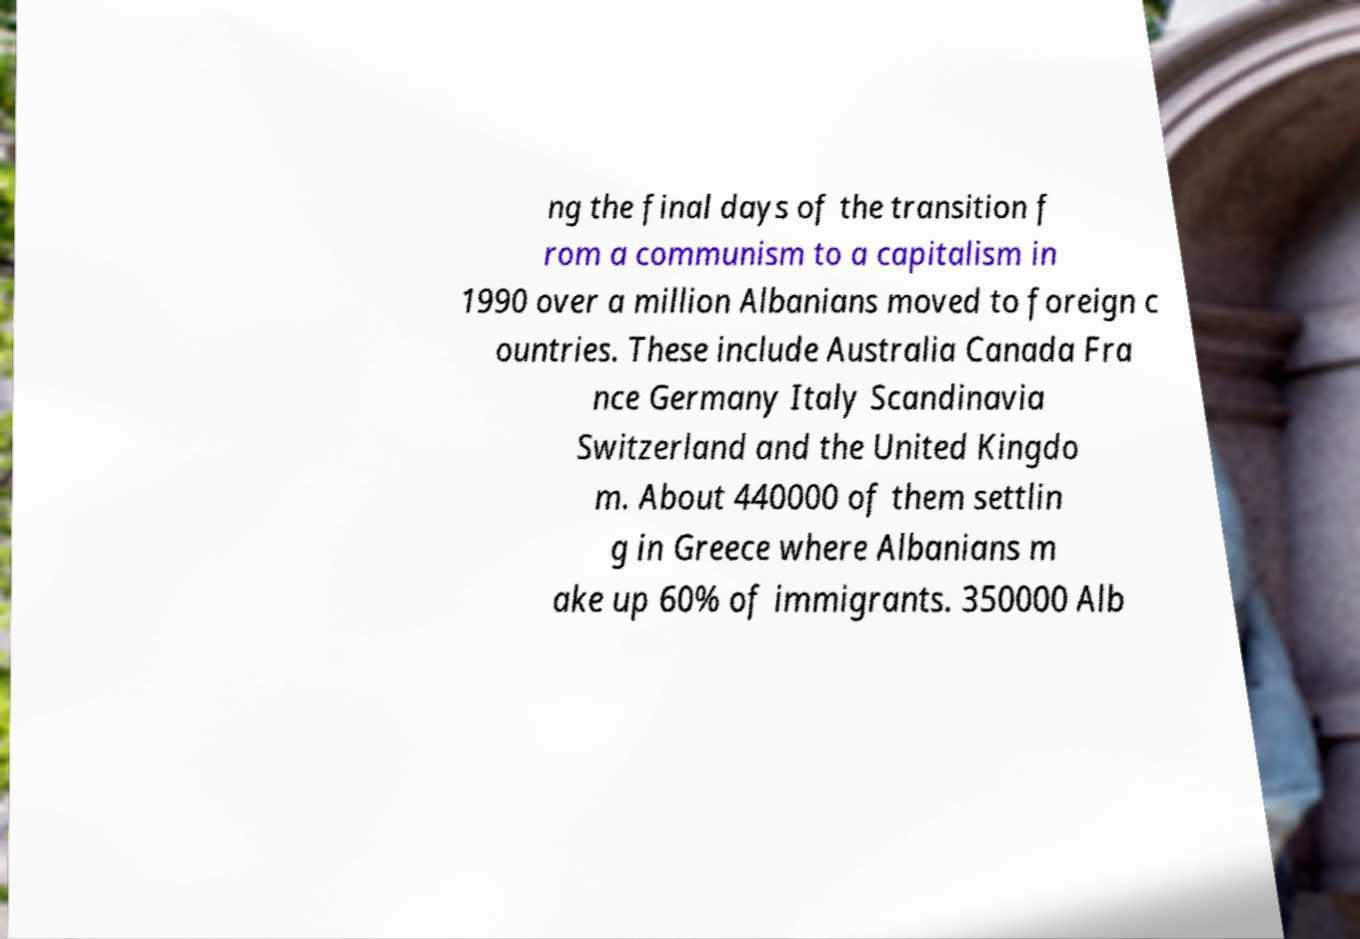Can you read and provide the text displayed in the image?This photo seems to have some interesting text. Can you extract and type it out for me? ng the final days of the transition f rom a communism to a capitalism in 1990 over a million Albanians moved to foreign c ountries. These include Australia Canada Fra nce Germany Italy Scandinavia Switzerland and the United Kingdo m. About 440000 of them settlin g in Greece where Albanians m ake up 60% of immigrants. 350000 Alb 